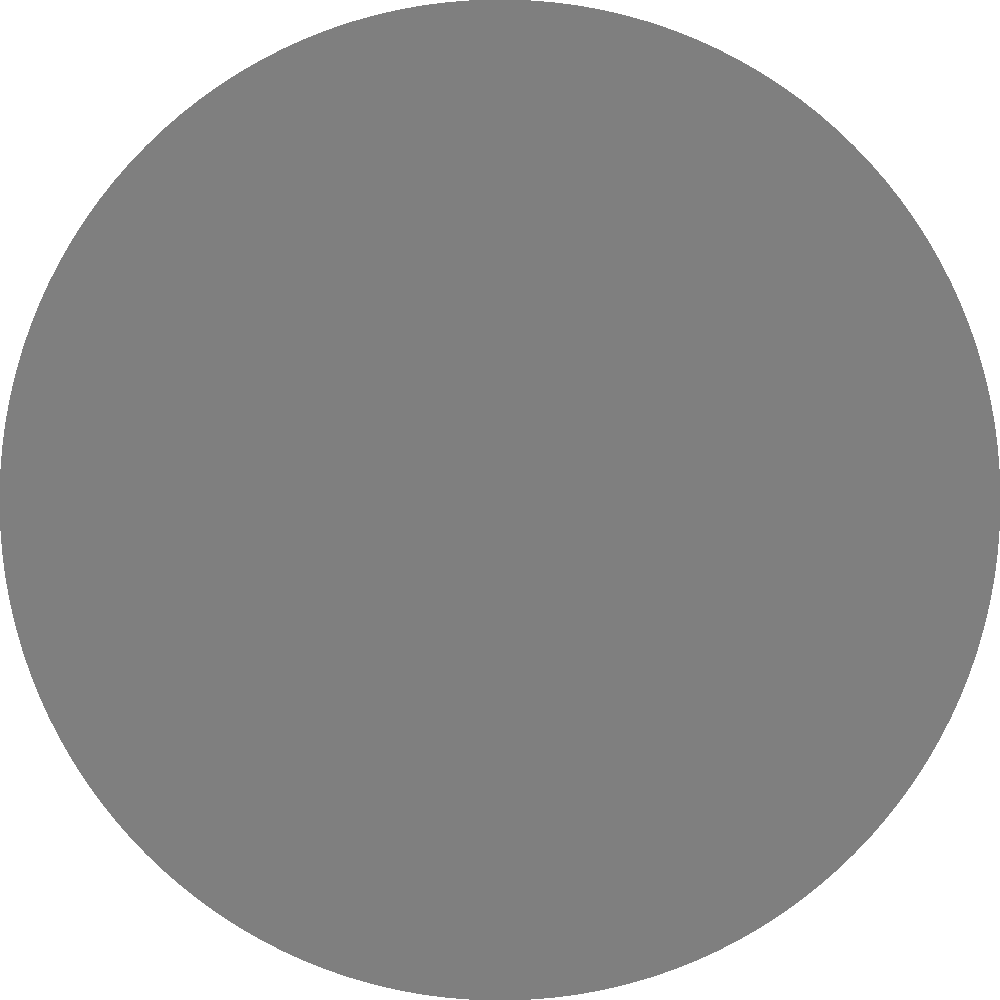As you delve into the history of the Laune Rangers, you come across an old photograph of your great-grandfather's football team standing near an electrical power line. This sparks your curiosity about the physics behind electrical engineering. Consider a long, straight conductor carrying a current $I$ as shown in the cross-sectional view above. Using Ampère's law, how would you express the magnetic field strength $B$ at a distance $r$ from the center of the conductor? Let's approach this step-by-step, relating it to the historical context:

1) Ampère's law states that the line integral of the magnetic field around a closed loop is proportional to the current enclosed by that loop. In mathematical terms:

   $$\oint \vec{B} \cdot d\vec{l} = \mu_0 I_{enc}$$

2) For a long, straight conductor, the magnetic field forms circular loops around the wire, much like the circular formations your great-grandfather's team might have used in training.

3) Due to the symmetry of the problem, the magnetic field strength $B$ is constant along any circular path centered on the wire.

4) The path length for this circular loop is the circumference of the circle: $2\pi r$.

5) Substituting these into Ampère's law:

   $$B(2\pi r) = \mu_0 I$$

6) Solving for $B$:

   $$B = \frac{\mu_0 I}{2\pi r}$$

7) Here, $\mu_0$ is the permeability of free space, a constant equal to $4\pi \times 10^{-7}$ T·m/A.

This equation shows that the magnetic field strength is directly proportional to the current and inversely proportional to the distance from the wire, much like how the influence of a star player (like your great-grandfather) might have been stronger closer to him on the field.
Answer: $B = \frac{\mu_0 I}{2\pi r}$ 